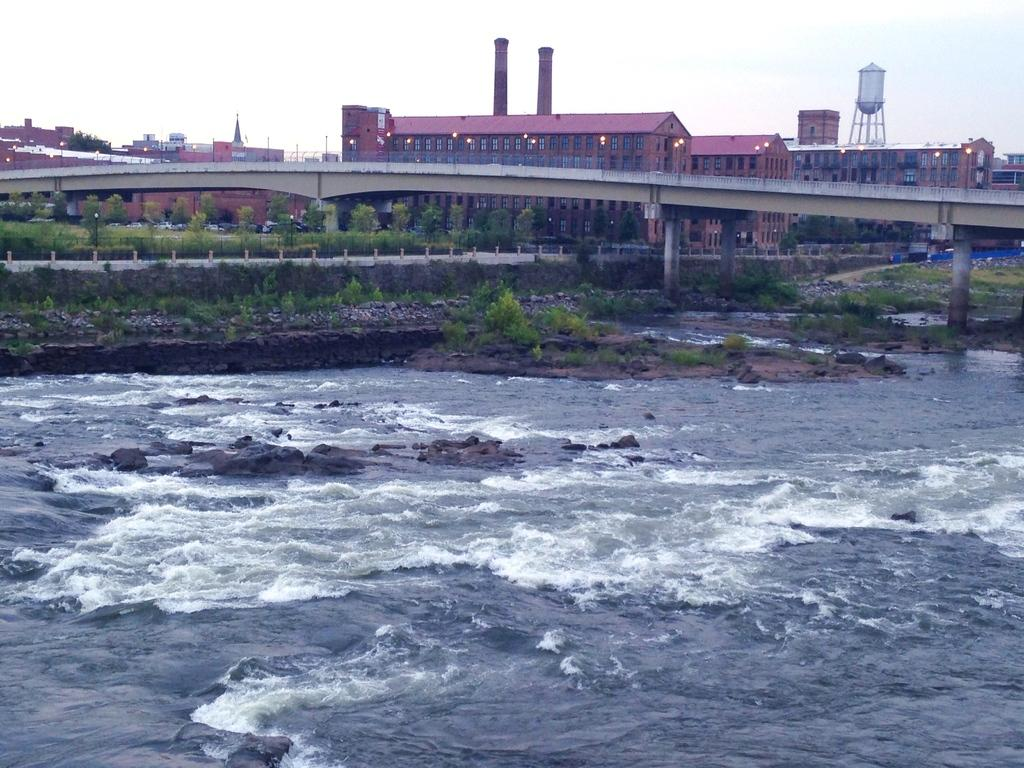What is the primary element visible in the image? There is water in the image. What other natural elements can be seen in the image? There are stones, plants, grass, and trees visible in the image. Are there any man-made structures in the image? Yes, there is a road, a bridge, and buildings in the image. What is visible in the background of the image? There are buildings and trees in the background of the image. What part of the natural environment is visible in the image? The sky is visible in the image. What type of hair can be seen on the giants in the image? There are no giants present in the image, so there is no hair to be seen. 